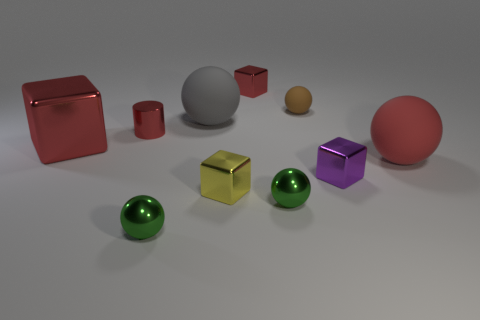Subtract all small brown spheres. How many spheres are left? 4 Subtract all red balls. How many balls are left? 4 Subtract all purple balls. Subtract all blue cylinders. How many balls are left? 5 Subtract all cubes. How many objects are left? 6 Subtract all green matte balls. Subtract all small purple blocks. How many objects are left? 9 Add 2 tiny brown matte spheres. How many tiny brown matte spheres are left? 3 Add 5 tiny green spheres. How many tiny green spheres exist? 7 Subtract 0 blue cubes. How many objects are left? 10 